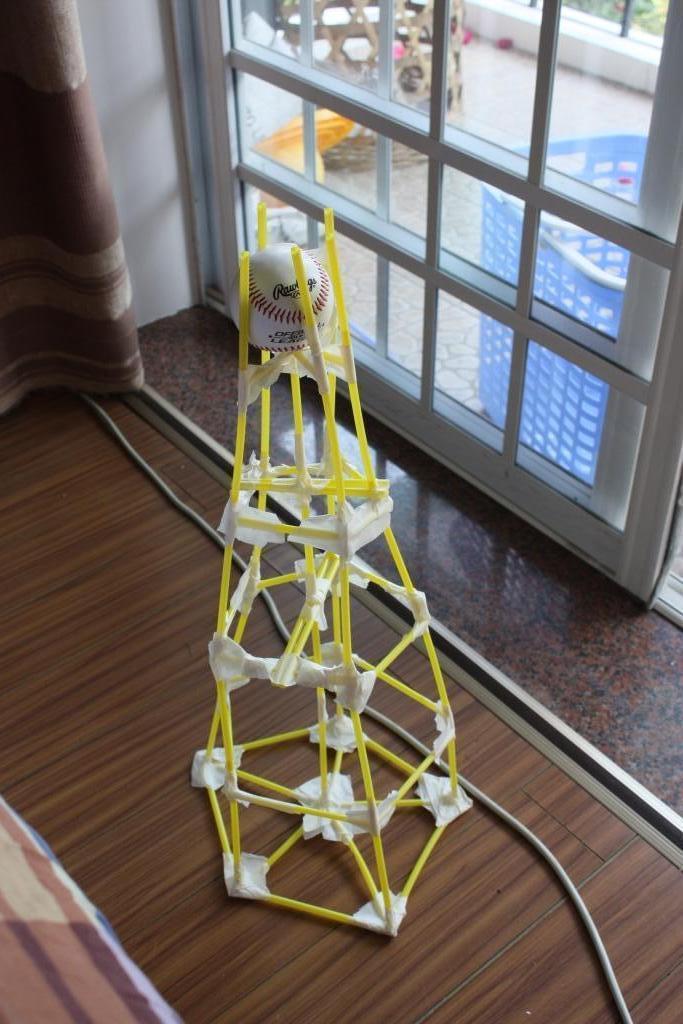Describe this image in one or two sentences. In this image we can see one curtain near the wall on the top left side of the image, one object on the floor on the bottom left side corner of the image, one object with the ball on the floor, one wire on the floor, one basket near the white object which looks like a door, some objects on the floor in the balcony, it looks like a plant and grass on the ground at the top right side corner of the image. 